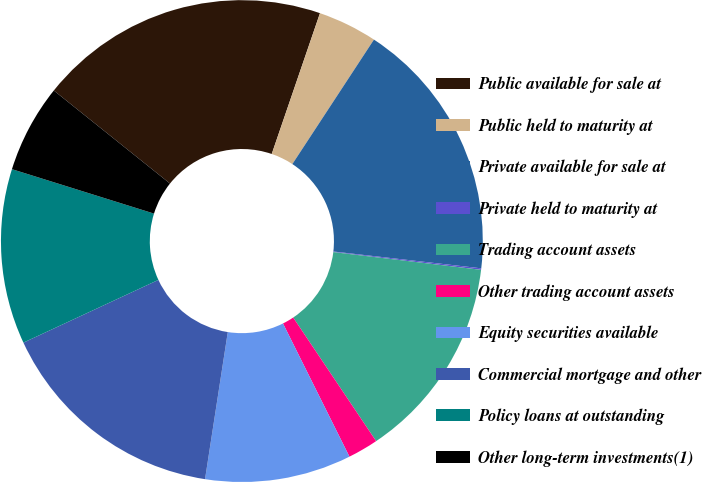Convert chart to OTSL. <chart><loc_0><loc_0><loc_500><loc_500><pie_chart><fcel>Public available for sale at<fcel>Public held to maturity at<fcel>Private available for sale at<fcel>Private held to maturity at<fcel>Trading account assets<fcel>Other trading account assets<fcel>Equity securities available<fcel>Commercial mortgage and other<fcel>Policy loans at outstanding<fcel>Other long-term investments(1)<nl><fcel>19.51%<fcel>3.98%<fcel>17.57%<fcel>0.1%<fcel>13.69%<fcel>2.04%<fcel>9.81%<fcel>15.63%<fcel>11.75%<fcel>5.92%<nl></chart> 